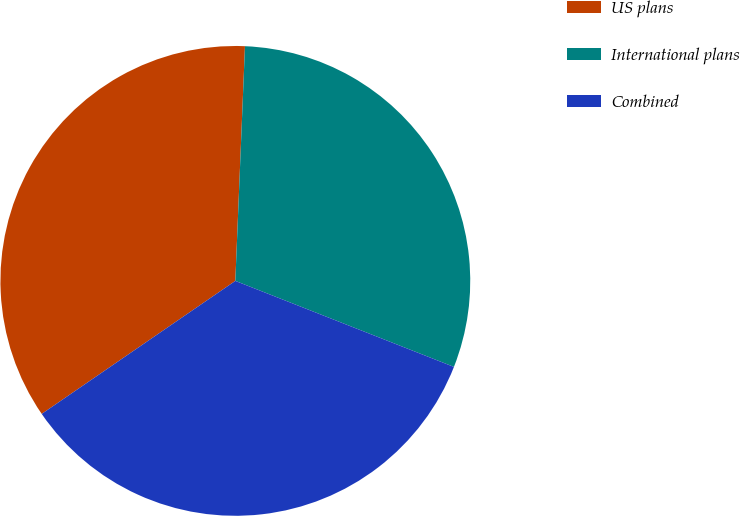Convert chart. <chart><loc_0><loc_0><loc_500><loc_500><pie_chart><fcel>US plans<fcel>International plans<fcel>Combined<nl><fcel>35.23%<fcel>30.31%<fcel>34.45%<nl></chart> 